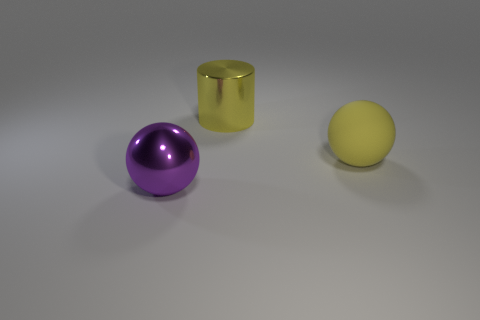Is there any other thing that has the same size as the purple thing?
Ensure brevity in your answer.  Yes. What number of things are metallic cylinders or rubber things?
Your answer should be very brief. 2. What is the shape of the object that is the same material as the large cylinder?
Offer a terse response. Sphere. What size is the metallic object behind the yellow object in front of the large yellow metal cylinder?
Keep it short and to the point. Large. How many small things are either metal balls or red balls?
Your answer should be very brief. 0. How many other things are there of the same color as the metal cylinder?
Give a very brief answer. 1. Is the yellow cylinder made of the same material as the sphere that is behind the purple thing?
Provide a succinct answer. No. Is the number of balls that are on the left side of the large cylinder greater than the number of yellow spheres in front of the rubber thing?
Your response must be concise. Yes. The big metallic object behind the large metal thing in front of the large yellow cylinder is what color?
Give a very brief answer. Yellow. How many spheres are large shiny objects or large yellow things?
Make the answer very short. 2. 